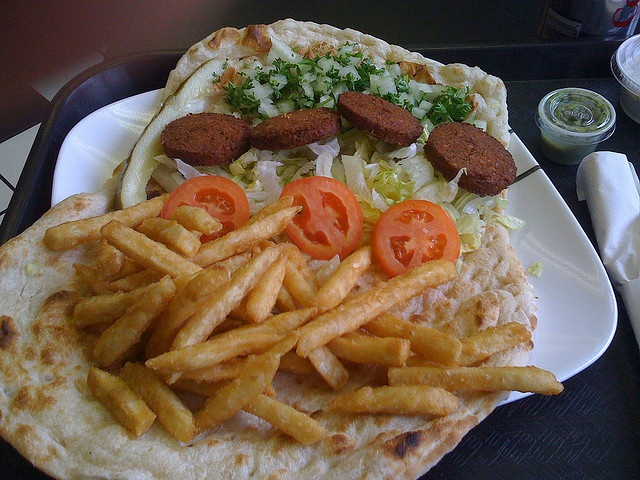Describe the objects in this image and their specific colors. I can see dining table in black, darkgray, olive, maroon, and tan tones and pizza in black, olive, darkgray, tan, and maroon tones in this image. 